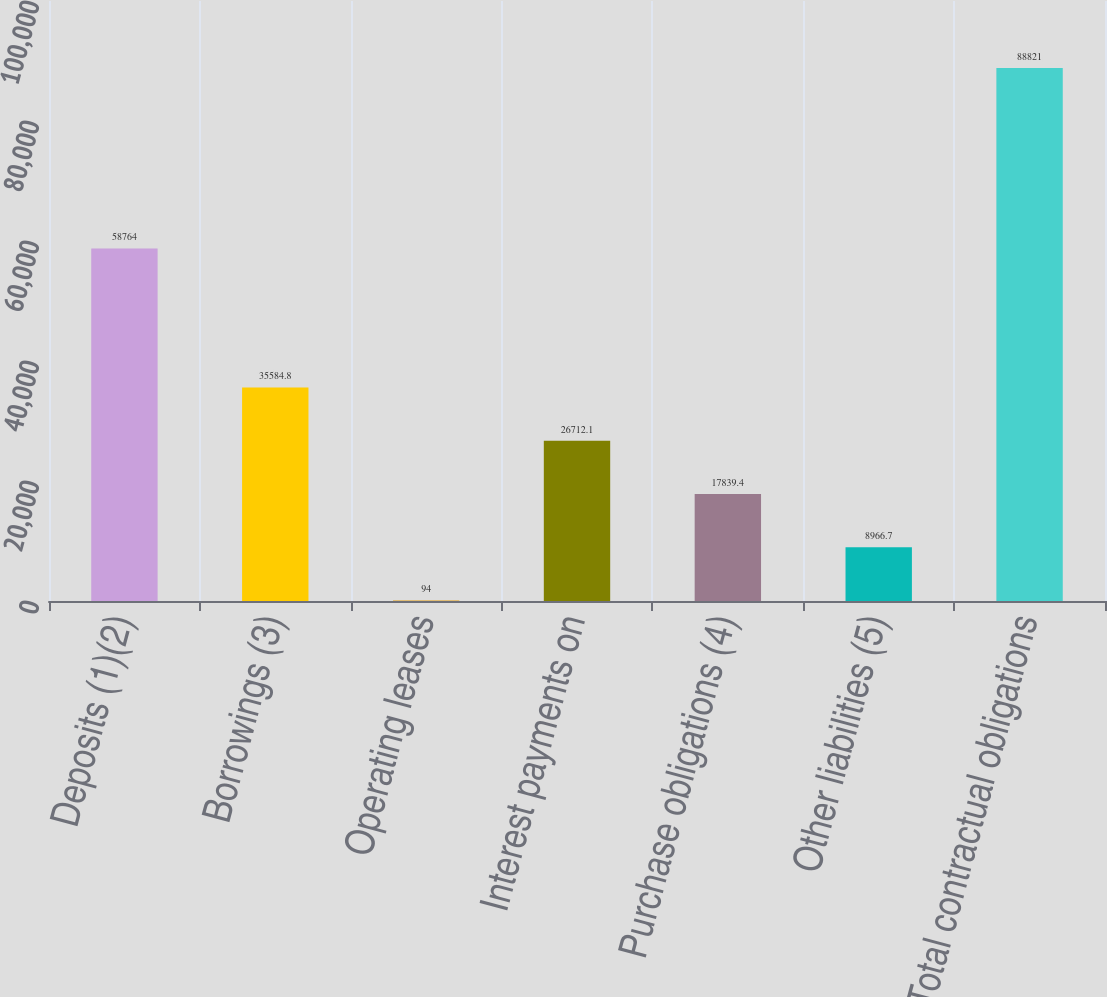Convert chart to OTSL. <chart><loc_0><loc_0><loc_500><loc_500><bar_chart><fcel>Deposits (1)(2)<fcel>Borrowings (3)<fcel>Operating leases<fcel>Interest payments on<fcel>Purchase obligations (4)<fcel>Other liabilities (5)<fcel>Total contractual obligations<nl><fcel>58764<fcel>35584.8<fcel>94<fcel>26712.1<fcel>17839.4<fcel>8966.7<fcel>88821<nl></chart> 